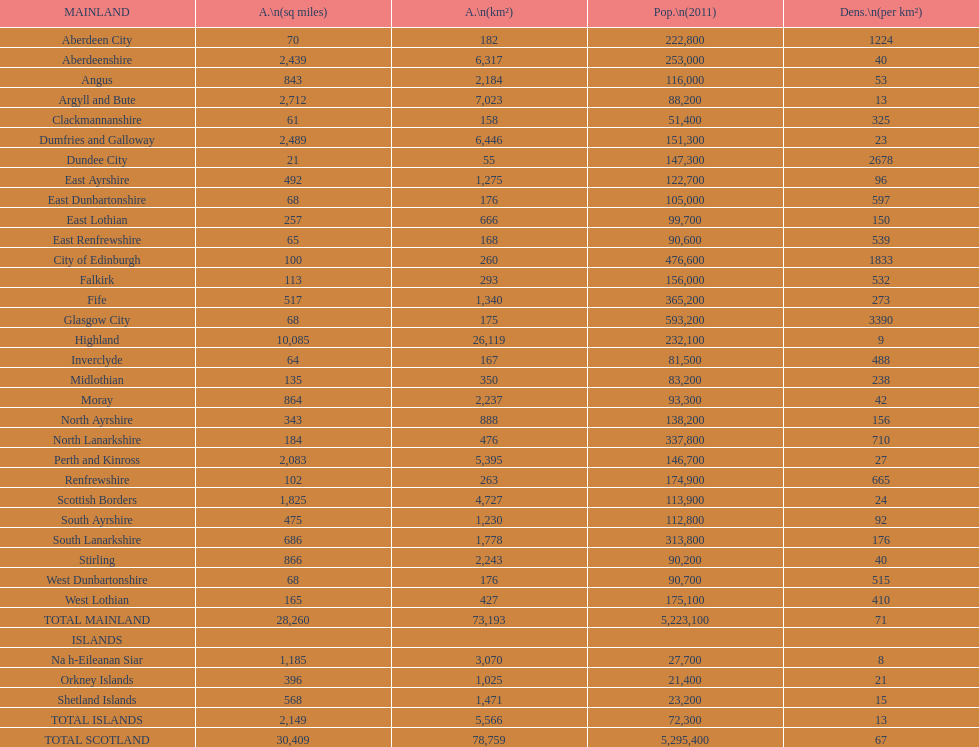What is the combined area of east lothian, angus, and dundee city? 1121. 